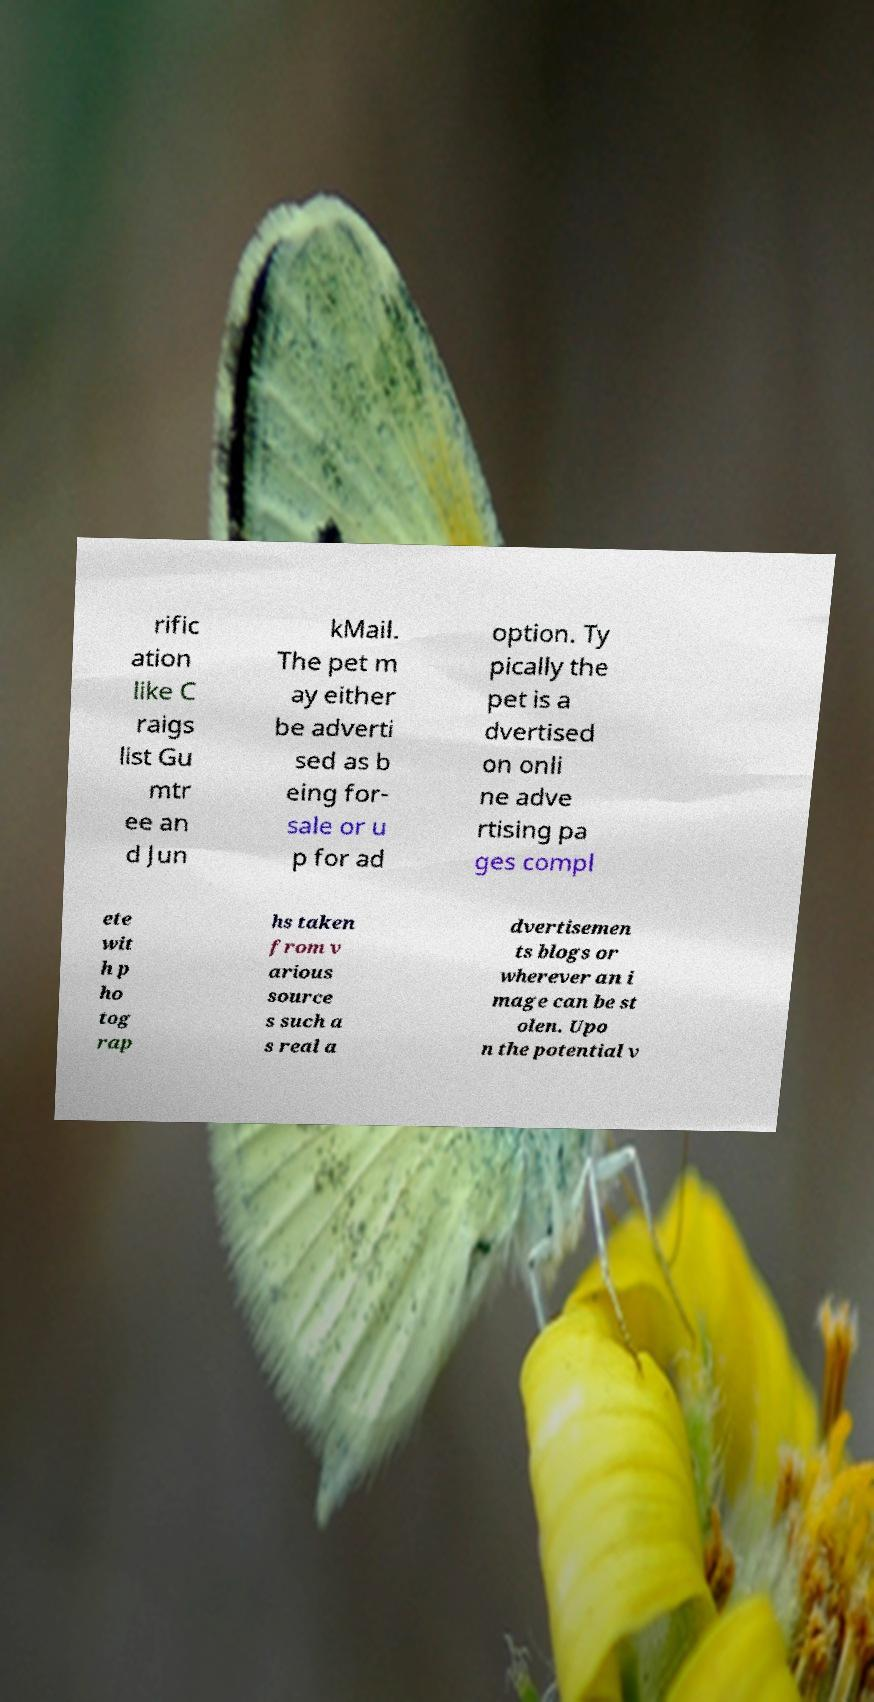Could you assist in decoding the text presented in this image and type it out clearly? rific ation like C raigs list Gu mtr ee an d Jun kMail. The pet m ay either be adverti sed as b eing for- sale or u p for ad option. Ty pically the pet is a dvertised on onli ne adve rtising pa ges compl ete wit h p ho tog rap hs taken from v arious source s such a s real a dvertisemen ts blogs or wherever an i mage can be st olen. Upo n the potential v 